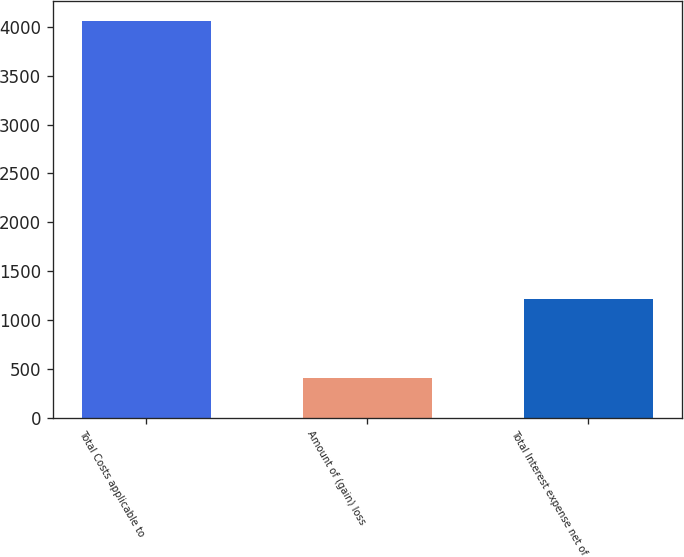Convert chart to OTSL. <chart><loc_0><loc_0><loc_500><loc_500><bar_chart><fcel>Total Costs applicable to<fcel>Amount of (gain) loss<fcel>Total Interest expense net of<nl><fcel>4062<fcel>408<fcel>1220<nl></chart> 